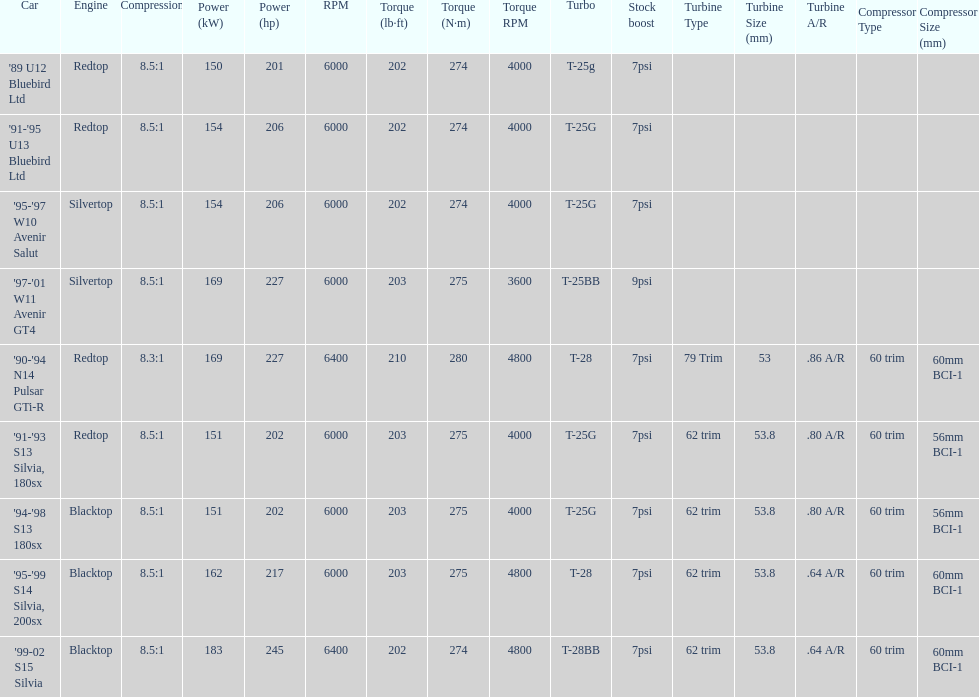What is his/her compression for the 90-94 n14 pulsar gti-r? 8.3:1. 